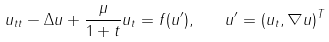<formula> <loc_0><loc_0><loc_500><loc_500>u _ { t t } - \Delta u + \frac { \mu } { 1 + t } u _ { t } = f ( u ^ { \prime } ) , \quad u ^ { \prime } = ( u _ { t } , \nabla u ) ^ { T }</formula> 